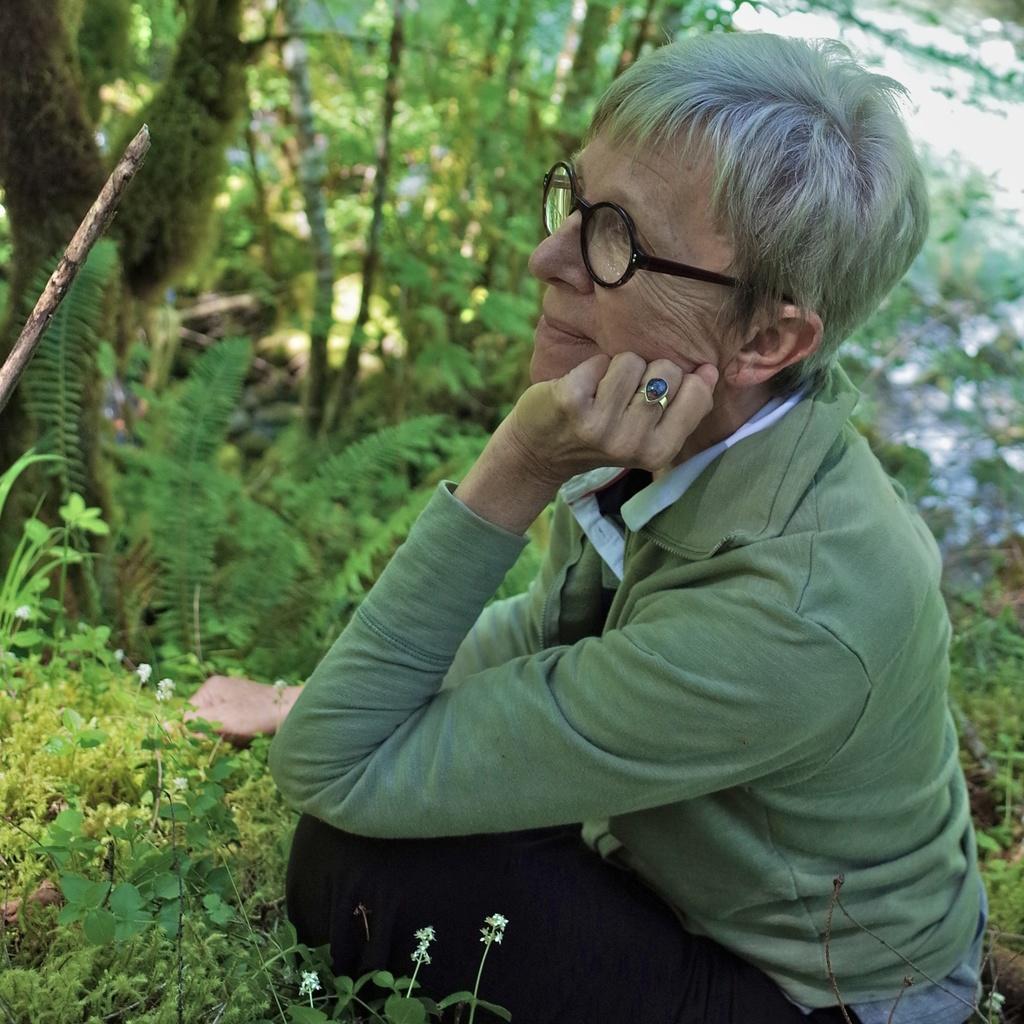Can you describe this image briefly? In this image there is a person sitting on the surface of the grass. In the background there are trees. 